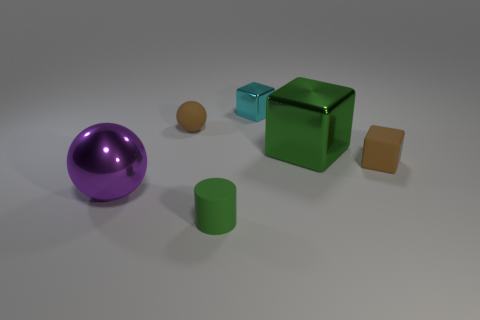Add 3 cyan metallic objects. How many objects exist? 9 Subtract all balls. How many objects are left? 4 Add 1 cyan metal objects. How many cyan metal objects exist? 2 Subtract 0 purple cubes. How many objects are left? 6 Subtract all matte cylinders. Subtract all small purple balls. How many objects are left? 5 Add 4 brown balls. How many brown balls are left? 5 